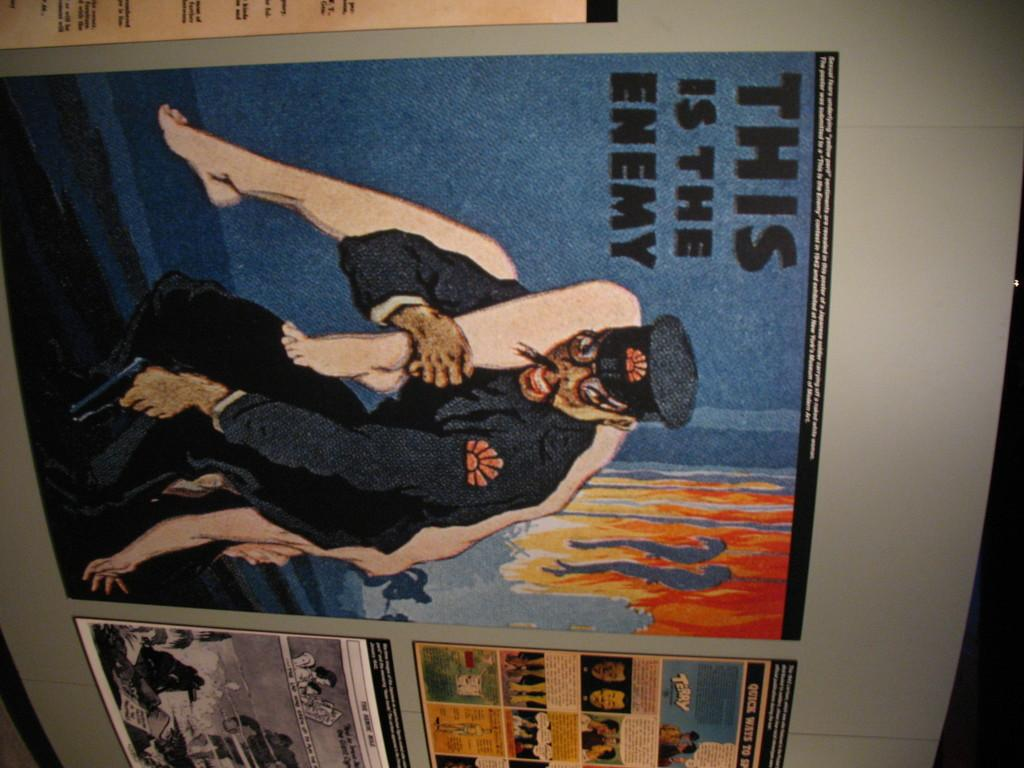Provide a one-sentence caption for the provided image. A piece of paper with the headline THIS IS THE ENEMY is attached to a wall. 